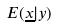<formula> <loc_0><loc_0><loc_500><loc_500>E ( \underline { x } | y )</formula> 